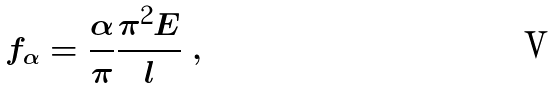Convert formula to latex. <formula><loc_0><loc_0><loc_500><loc_500>f _ { \alpha } = \frac { \alpha } { \pi } \frac { \pi ^ { 2 } E } { l } \ ,</formula> 